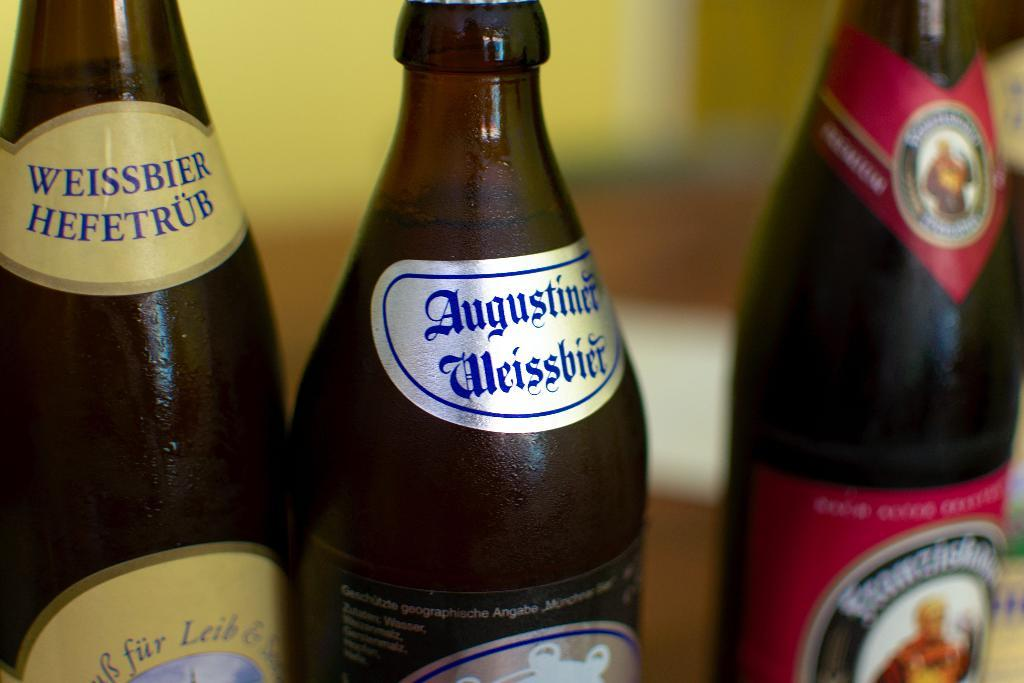<image>
Write a terse but informative summary of the picture. three bottles of beer in a row with the middle being augustiner 